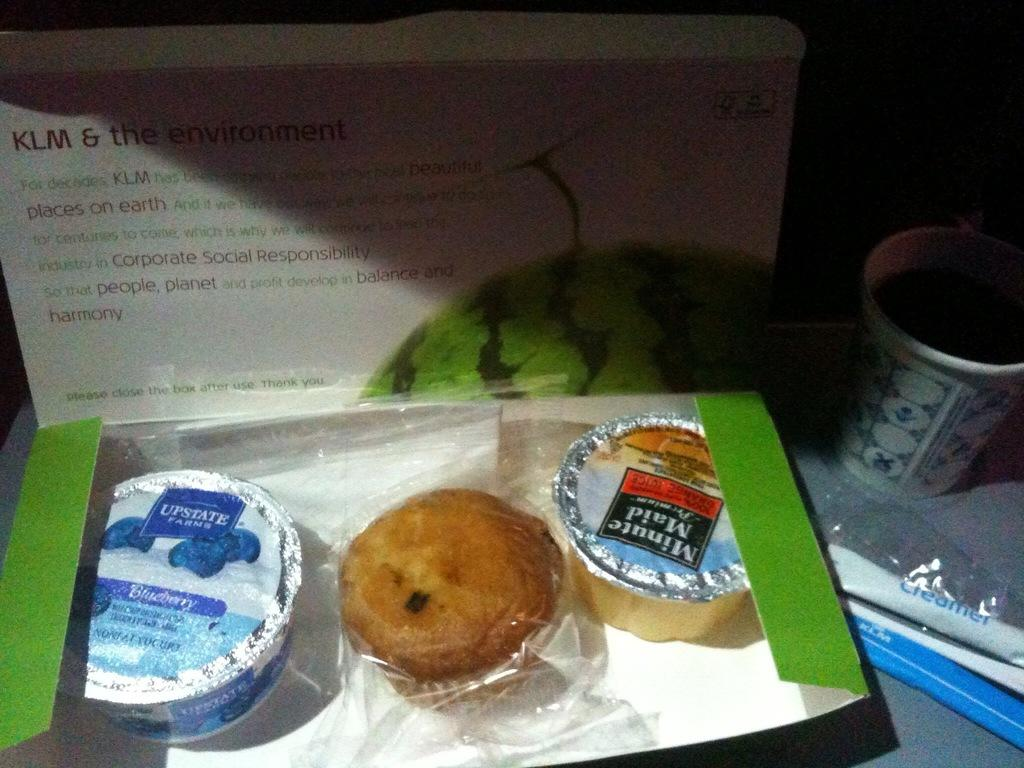What is one of the objects visible in the image? There is a box in the image. What else can be seen in the image? There is a board and a cup visible in the image. What is the purpose of the box in the image? The box contains cups and a muffin. What is written on the board in the image? Something is written on the board, but the specific message cannot be determined from the image. Can you see the face of the person who wrote on the board in the image? There is no face visible in the image, as it only shows a box, board, cup, and the objects inside the box. 